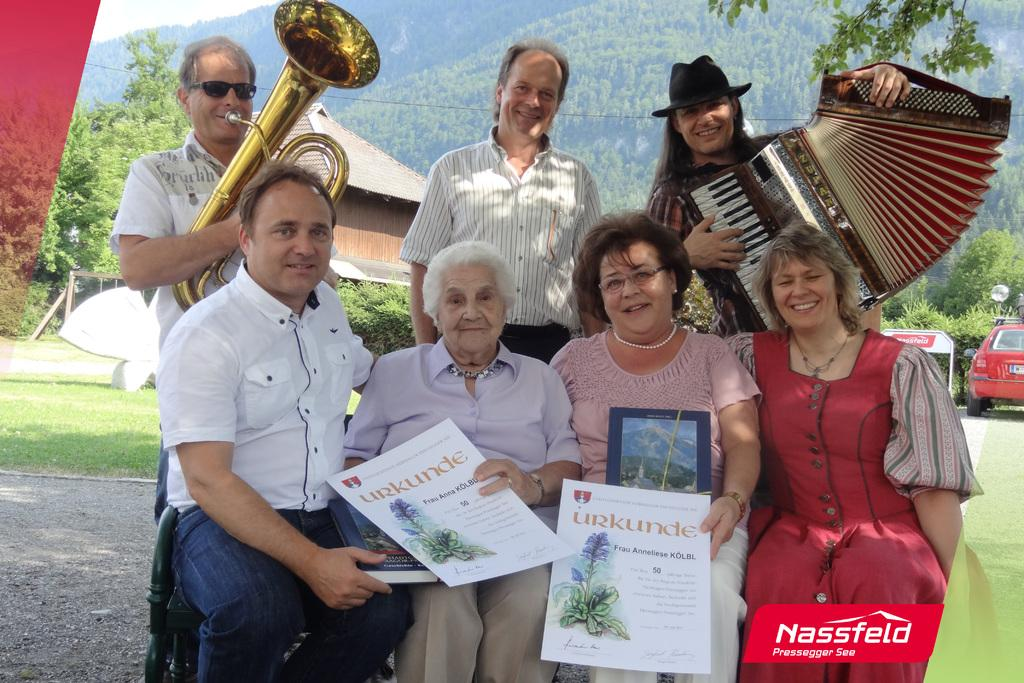<image>
Write a terse but informative summary of the picture. A group of musicians are posing with people holding a poster that says Urkunde. 